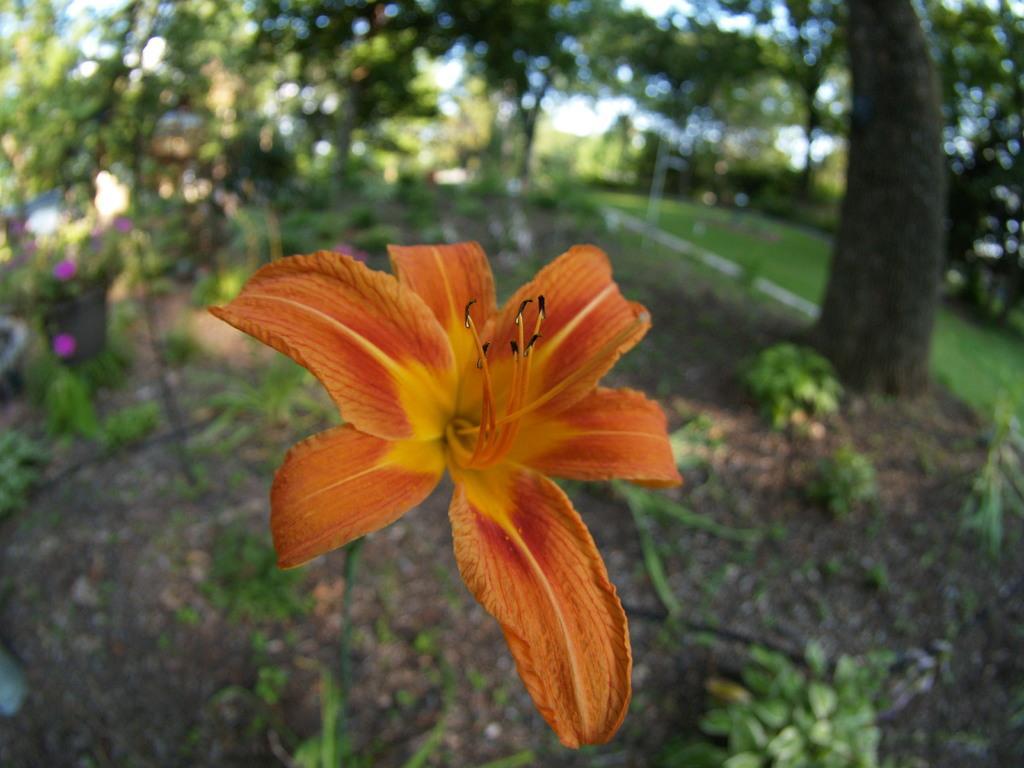Describe this image in one or two sentences. In the middle of this image, we can see there is an orange color flower of a plant. In the background, there are trees, plants and grass on the ground and there is sky. 